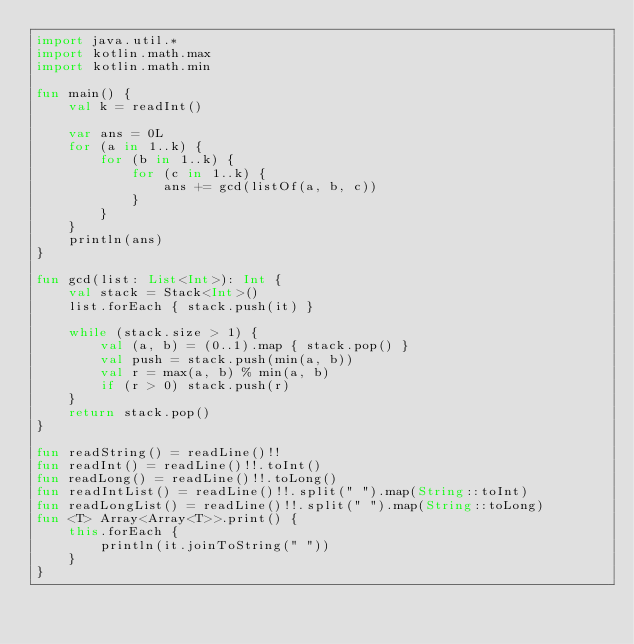Convert code to text. <code><loc_0><loc_0><loc_500><loc_500><_Kotlin_>import java.util.*
import kotlin.math.max
import kotlin.math.min

fun main() {
    val k = readInt()

    var ans = 0L
    for (a in 1..k) {
        for (b in 1..k) {
            for (c in 1..k) {
                ans += gcd(listOf(a, b, c))
            }
        }
    }
    println(ans)
}

fun gcd(list: List<Int>): Int {
    val stack = Stack<Int>()
    list.forEach { stack.push(it) }

    while (stack.size > 1) {
        val (a, b) = (0..1).map { stack.pop() }
        val push = stack.push(min(a, b))
        val r = max(a, b) % min(a, b)
        if (r > 0) stack.push(r)
    }
    return stack.pop()
}

fun readString() = readLine()!!
fun readInt() = readLine()!!.toInt()
fun readLong() = readLine()!!.toLong()
fun readIntList() = readLine()!!.split(" ").map(String::toInt)
fun readLongList() = readLine()!!.split(" ").map(String::toLong)
fun <T> Array<Array<T>>.print() {
    this.forEach {
        println(it.joinToString(" "))
    }
}</code> 